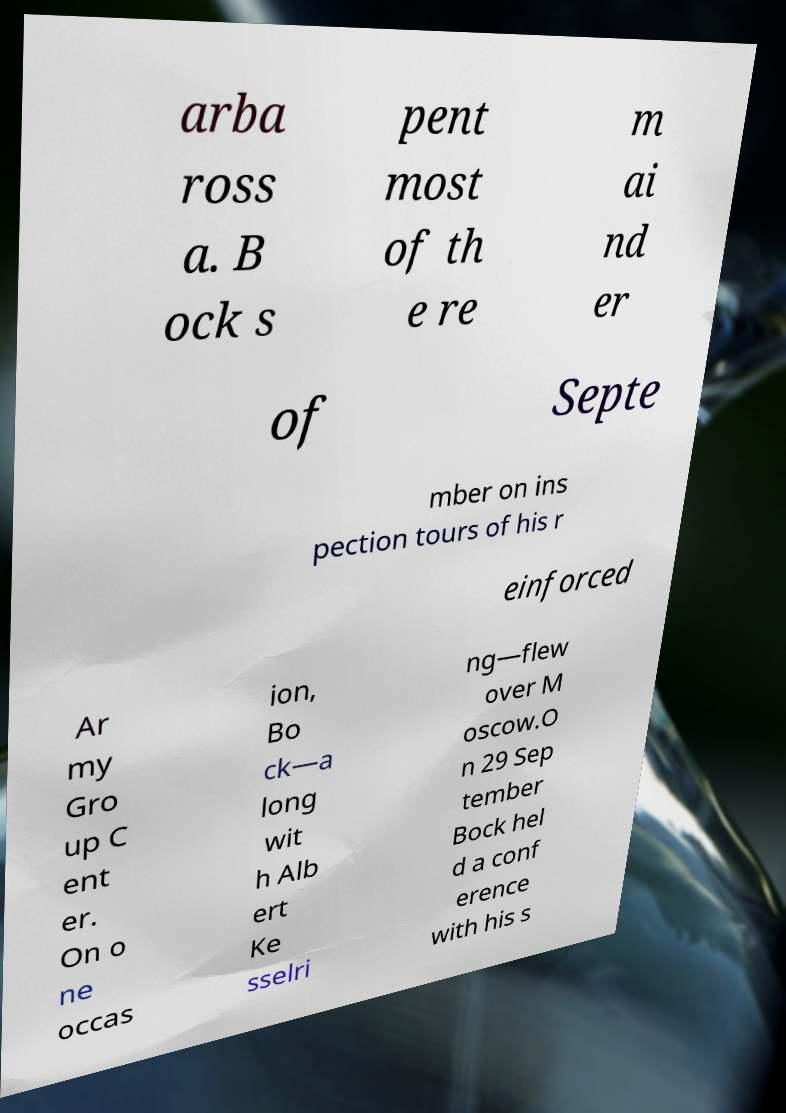I need the written content from this picture converted into text. Can you do that? arba ross a. B ock s pent most of th e re m ai nd er of Septe mber on ins pection tours of his r einforced Ar my Gro up C ent er. On o ne occas ion, Bo ck—a long wit h Alb ert Ke sselri ng—flew over M oscow.O n 29 Sep tember Bock hel d a conf erence with his s 